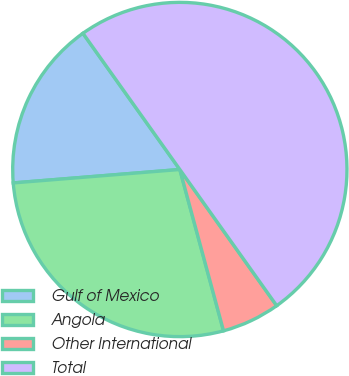<chart> <loc_0><loc_0><loc_500><loc_500><pie_chart><fcel>Gulf of Mexico<fcel>Angola<fcel>Other International<fcel>Total<nl><fcel>16.44%<fcel>27.93%<fcel>5.63%<fcel>50.0%<nl></chart> 